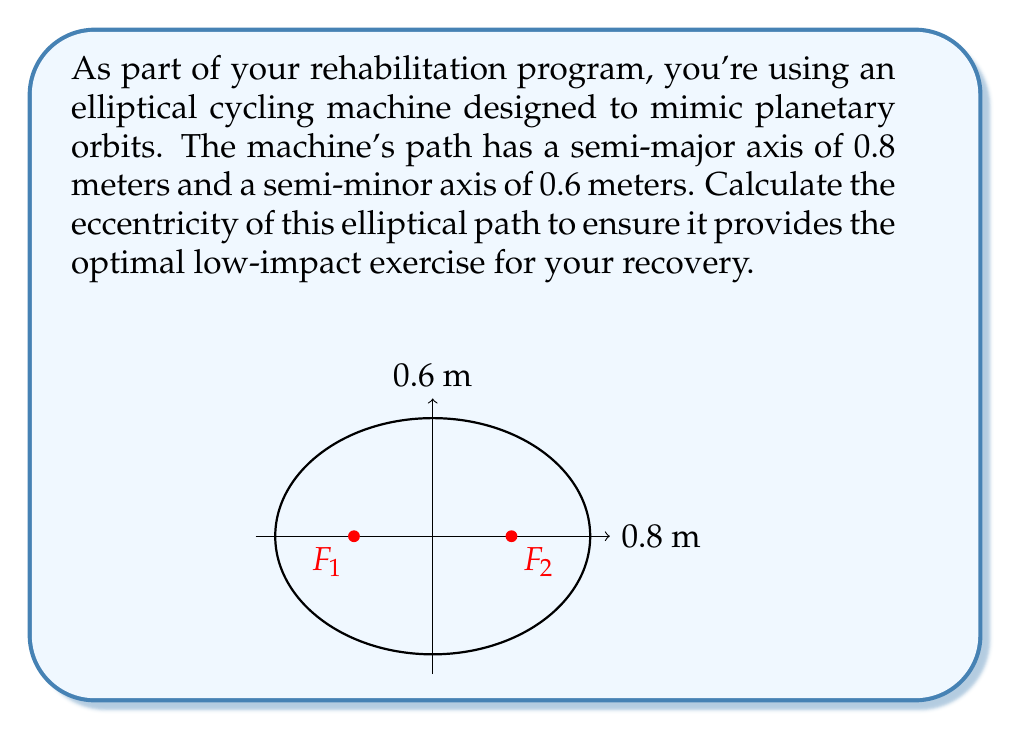Can you solve this math problem? Let's approach this step-by-step:

1) The eccentricity of an ellipse is defined as:

   $$e = \sqrt{1 - \frac{b^2}{a^2}}$$

   where $a$ is the semi-major axis and $b$ is the semi-minor axis.

2) We are given:
   $a = 0.8$ meters
   $b = 0.6$ meters

3) Let's substitute these values into the equation:

   $$e = \sqrt{1 - \frac{(0.6)^2}{(0.8)^2}}$$

4) Simplify inside the parentheses:

   $$e = \sqrt{1 - \frac{0.36}{0.64}}$$

5) Perform the division:

   $$e = \sqrt{1 - 0.5625}$$

6) Subtract:

   $$e = \sqrt{0.4375}$$

7) Take the square root:

   $$e \approx 0.6614$$

The eccentricity of the elliptical path is approximately 0.6614.
Answer: $e \approx 0.6614$ 